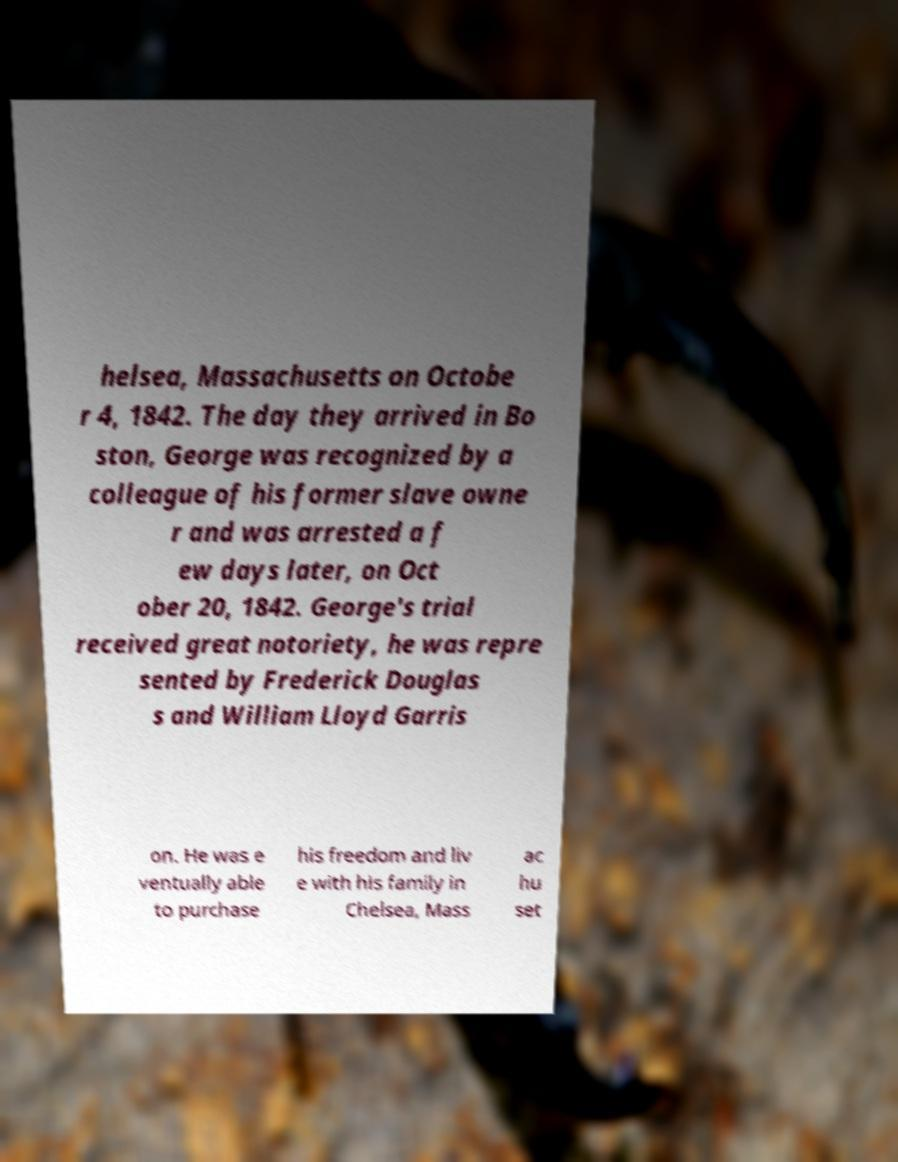There's text embedded in this image that I need extracted. Can you transcribe it verbatim? helsea, Massachusetts on Octobe r 4, 1842. The day they arrived in Bo ston, George was recognized by a colleague of his former slave owne r and was arrested a f ew days later, on Oct ober 20, 1842. George's trial received great notoriety, he was repre sented by Frederick Douglas s and William Lloyd Garris on. He was e ventually able to purchase his freedom and liv e with his family in Chelsea, Mass ac hu set 